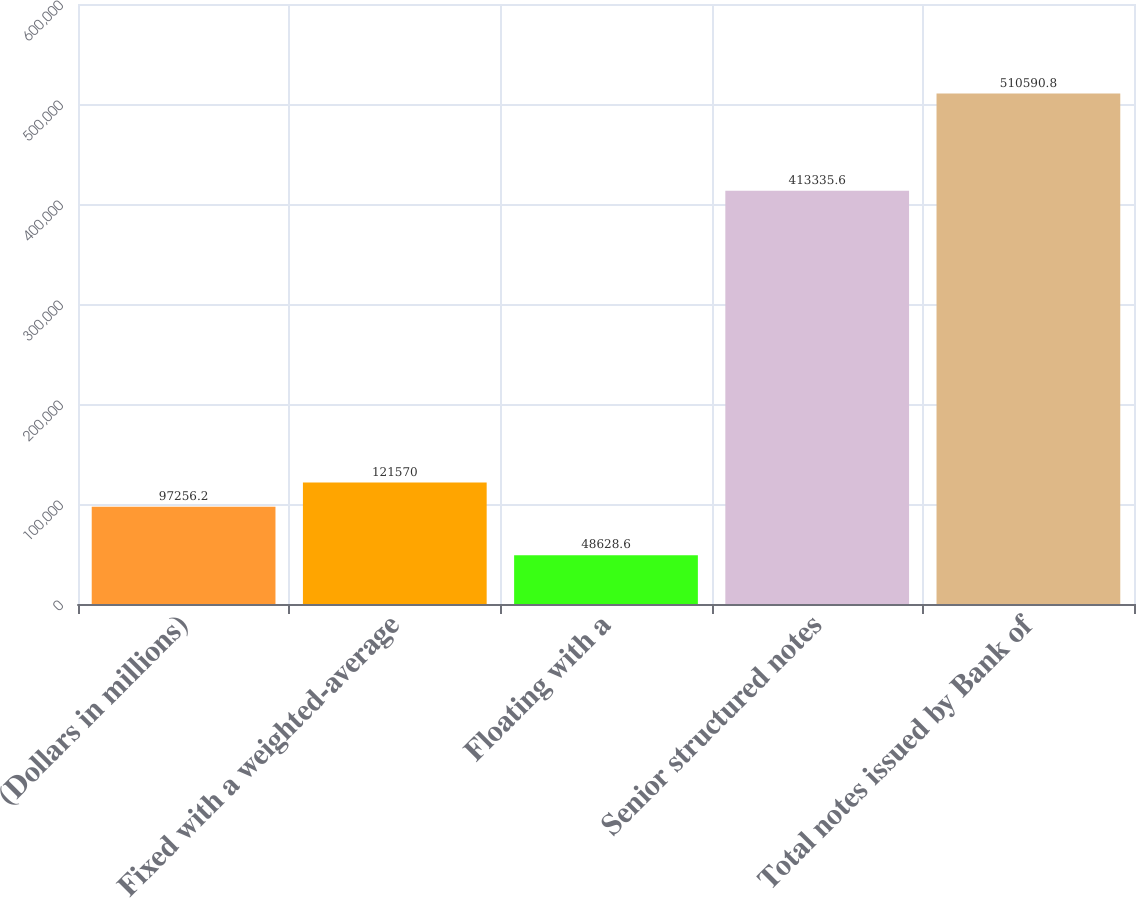<chart> <loc_0><loc_0><loc_500><loc_500><bar_chart><fcel>(Dollars in millions)<fcel>Fixed with a weighted-average<fcel>Floating with a<fcel>Senior structured notes<fcel>Total notes issued by Bank of<nl><fcel>97256.2<fcel>121570<fcel>48628.6<fcel>413336<fcel>510591<nl></chart> 